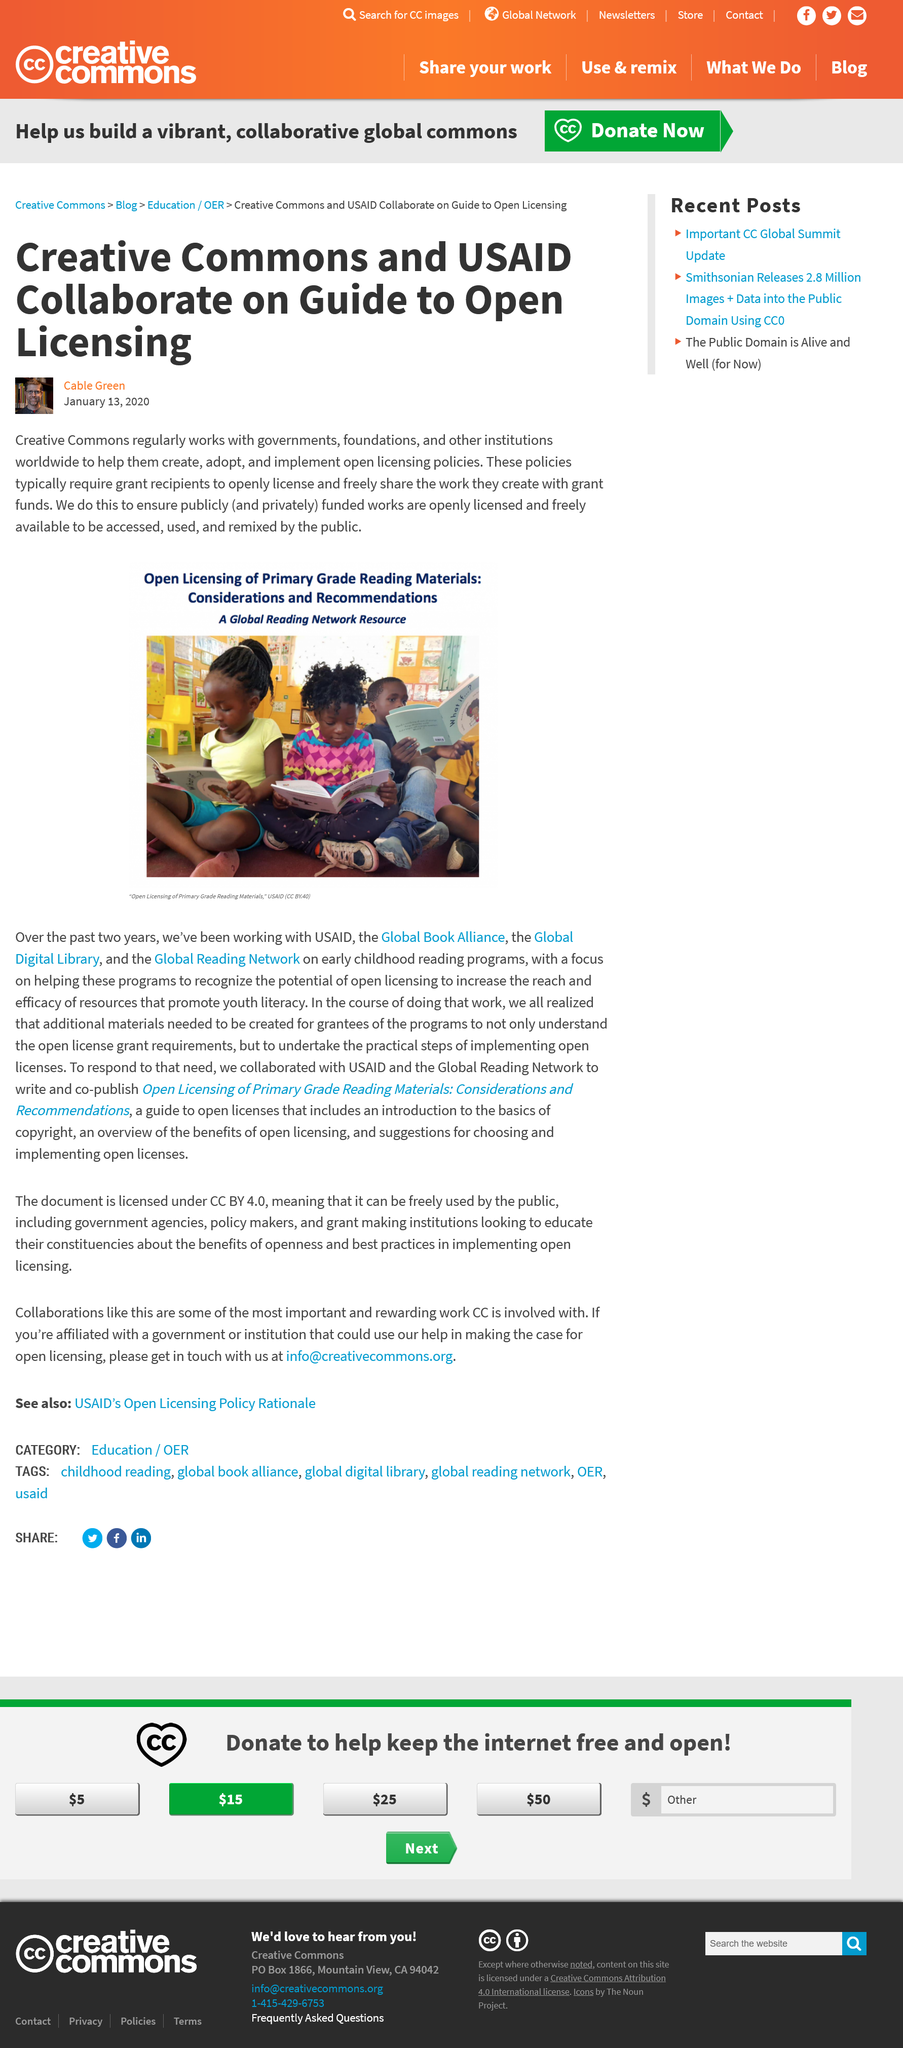Point out several critical features in this image. Creative Commons collaborates with governments, foundations, and other institutions globally to promote the use and sharing of creative works. Creative Commons helps to create, adopt, and implement open licensing policies that allow for the free use and sharing of creative works. The purpose of Creative Commons creating open licensing policies is to ensure that public and privately funded works are freely available for public access and use. 